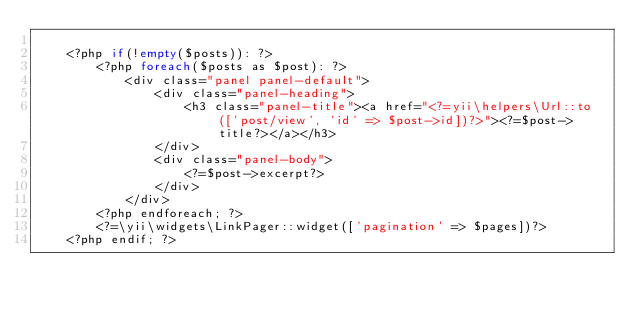<code> <loc_0><loc_0><loc_500><loc_500><_PHP_>
    <?php if(!empty($posts)): ?>
        <?php foreach($posts as $post): ?>
            <div class="panel panel-default">
                <div class="panel-heading">
                    <h3 class="panel-title"><a href="<?=yii\helpers\Url::to(['post/view', 'id' => $post->id])?>"><?=$post->title?></a></h3>
                </div>
                <div class="panel-body">
                    <?=$post->excerpt?>
                </div>
            </div>
        <?php endforeach; ?>
        <?=\yii\widgets\LinkPager::widget(['pagination' => $pages])?>
    <?php endif; ?>



</code> 